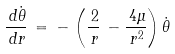<formula> <loc_0><loc_0><loc_500><loc_500>\frac { \, d \dot { \theta } } { \, d r } \, = \, - \, \left ( \frac { \, 2 } { \, r } \, - \frac { \, 4 \mu } { \, r ^ { 2 } } \right ) \dot { \theta }</formula> 